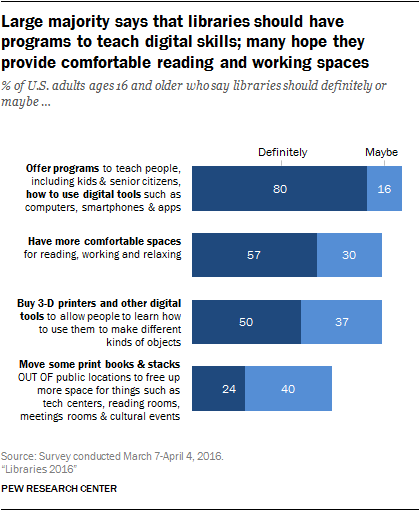List a handful of essential elements in this visual. I am unable to complete this request as I do not have enough information to accurately determine the value of the longest blue bar. Can you please provide more context or clarification? The average of the two smallest blue bars is 37. 